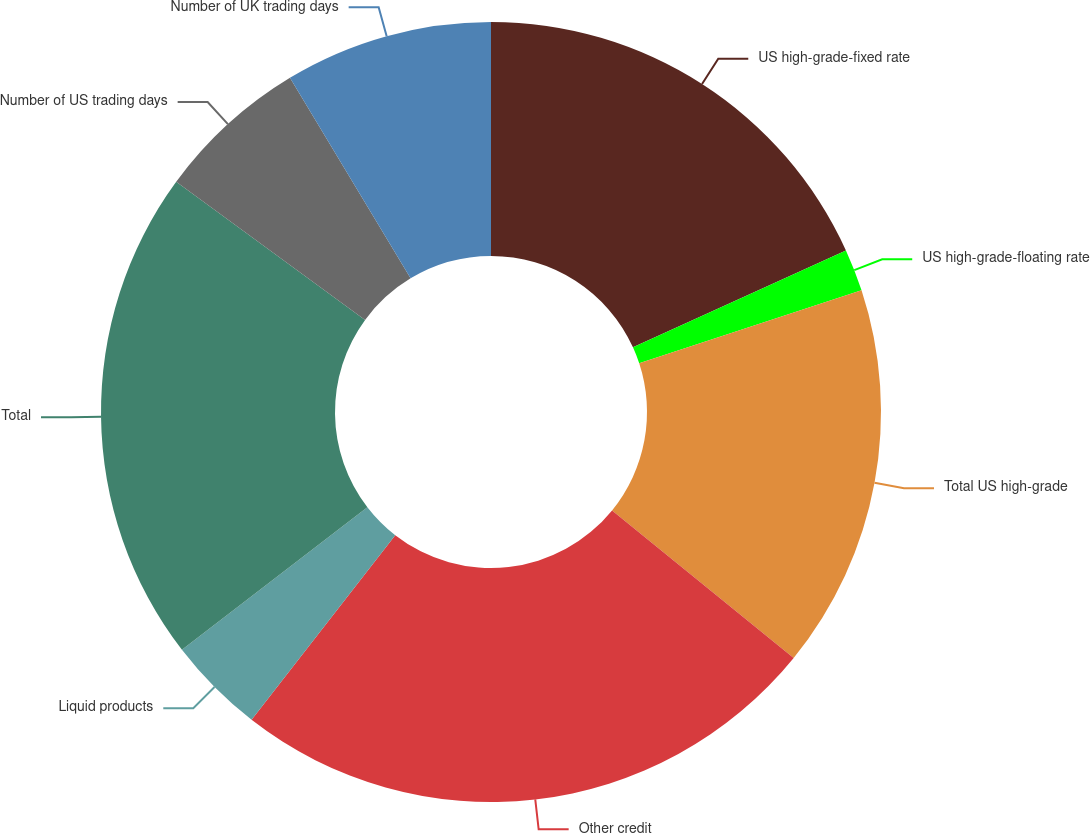Convert chart. <chart><loc_0><loc_0><loc_500><loc_500><pie_chart><fcel>US high-grade-fixed rate<fcel>US high-grade-floating rate<fcel>Total US high-grade<fcel>Other credit<fcel>Liquid products<fcel>Total<fcel>Number of US trading days<fcel>Number of UK trading days<nl><fcel>18.2%<fcel>1.75%<fcel>15.91%<fcel>24.66%<fcel>4.04%<fcel>20.49%<fcel>6.33%<fcel>8.62%<nl></chart> 